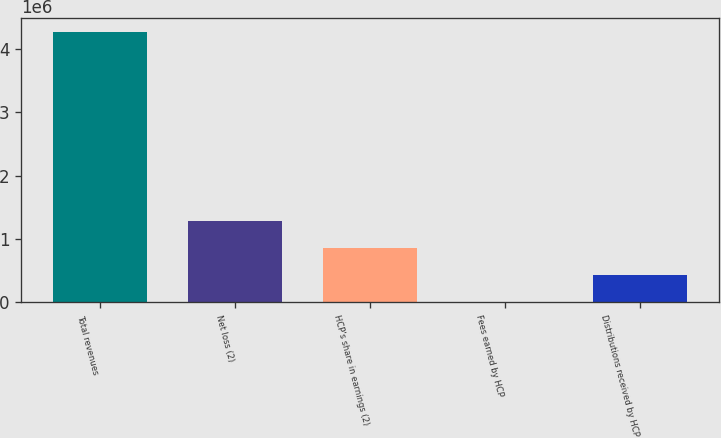<chart> <loc_0><loc_0><loc_500><loc_500><bar_chart><fcel>Total revenues<fcel>Net loss (2)<fcel>HCP's share in earnings (2)<fcel>Fees earned by HCP<fcel>Distributions received by HCP<nl><fcel>4.26916e+06<fcel>1.28204e+06<fcel>855309<fcel>1847<fcel>428578<nl></chart> 